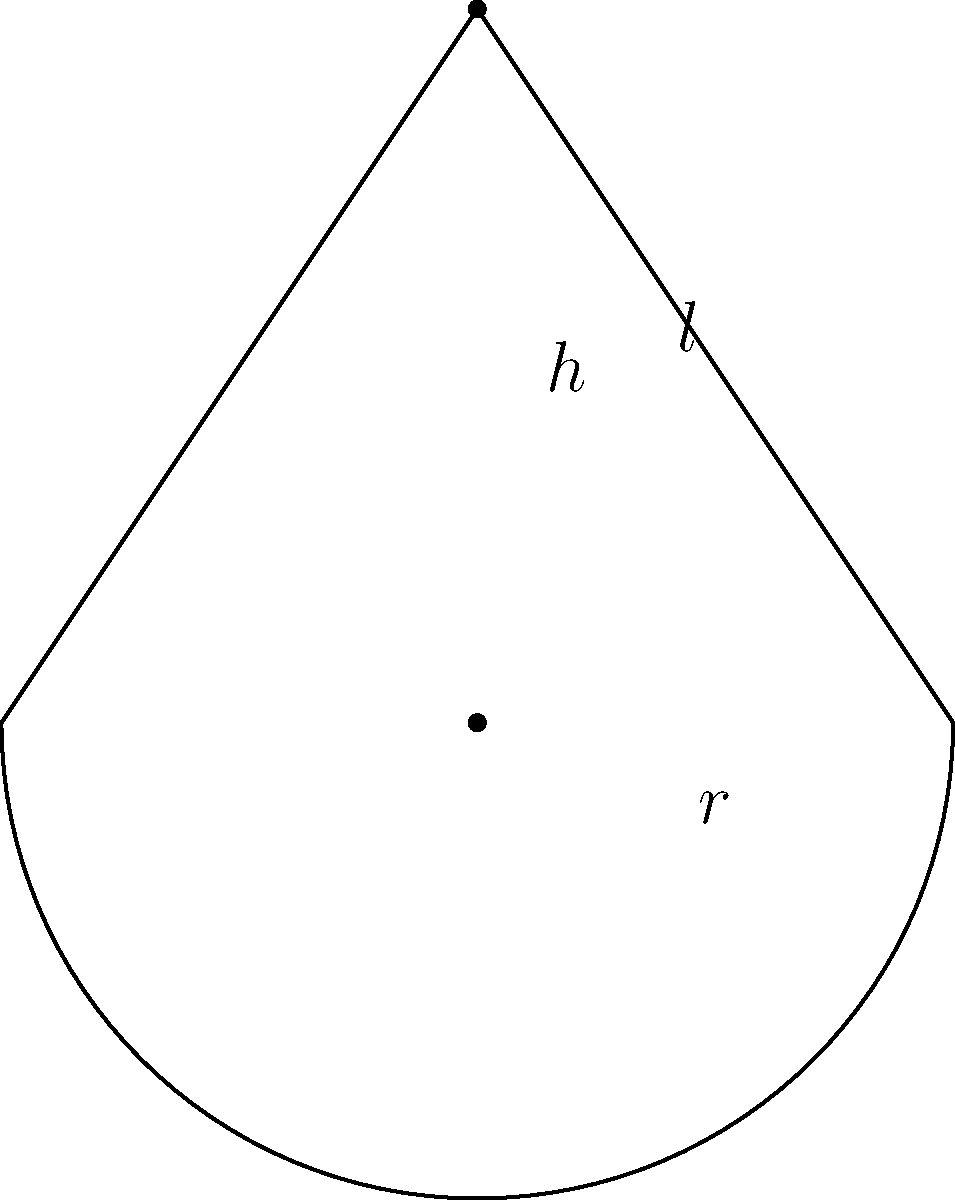As a seamstress specializing in vintage-inspired wedding dresses, you've been asked to create a unique conical veil for a bride. The veil has a base radius of 24 inches and a slant height of 32 inches. Calculate the surface area of the veil, excluding the circular base. Round your answer to the nearest square inch. To find the surface area of a conical veil (excluding the base), we need to use the formula for the lateral surface area of a cone:

$$A = \pi r l$$

Where:
$A$ = lateral surface area
$r$ = radius of the base
$l$ = slant height of the cone

Given:
$r = 24$ inches
$l = 32$ inches

Let's substitute these values into the formula:

$$A = \pi \cdot 24 \cdot 32$$

Now, let's calculate:

1) First, multiply the numbers:
   $$A = \pi \cdot 768$$

2) Now, multiply by $\pi$:
   $$A = 2,411.52...$$

3) Rounding to the nearest square inch:
   $$A \approx 2,412 \text{ sq inches}$$

Therefore, the surface area of the conical veil, excluding the base, is approximately 2,412 square inches.
Answer: 2,412 sq inches 